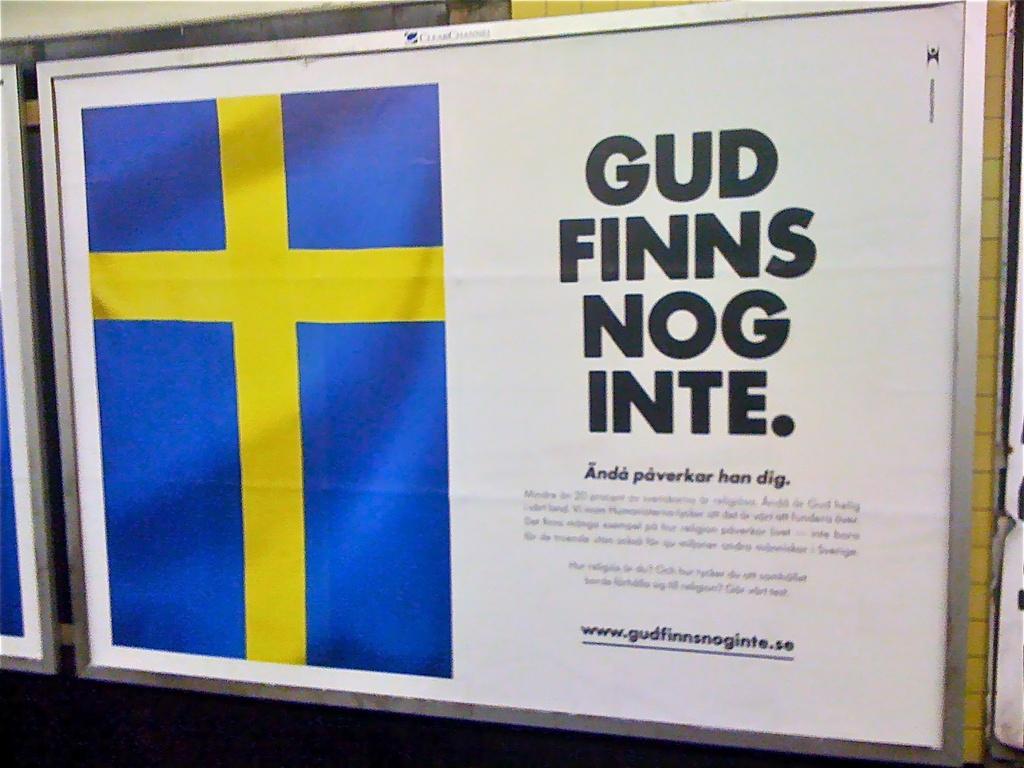What does it say on the billboard?
Keep it short and to the point. Gud finns nog inte. What website is written on the bottom of the sign?
Provide a succinct answer. Www.gudfinnsnoginte.se. 